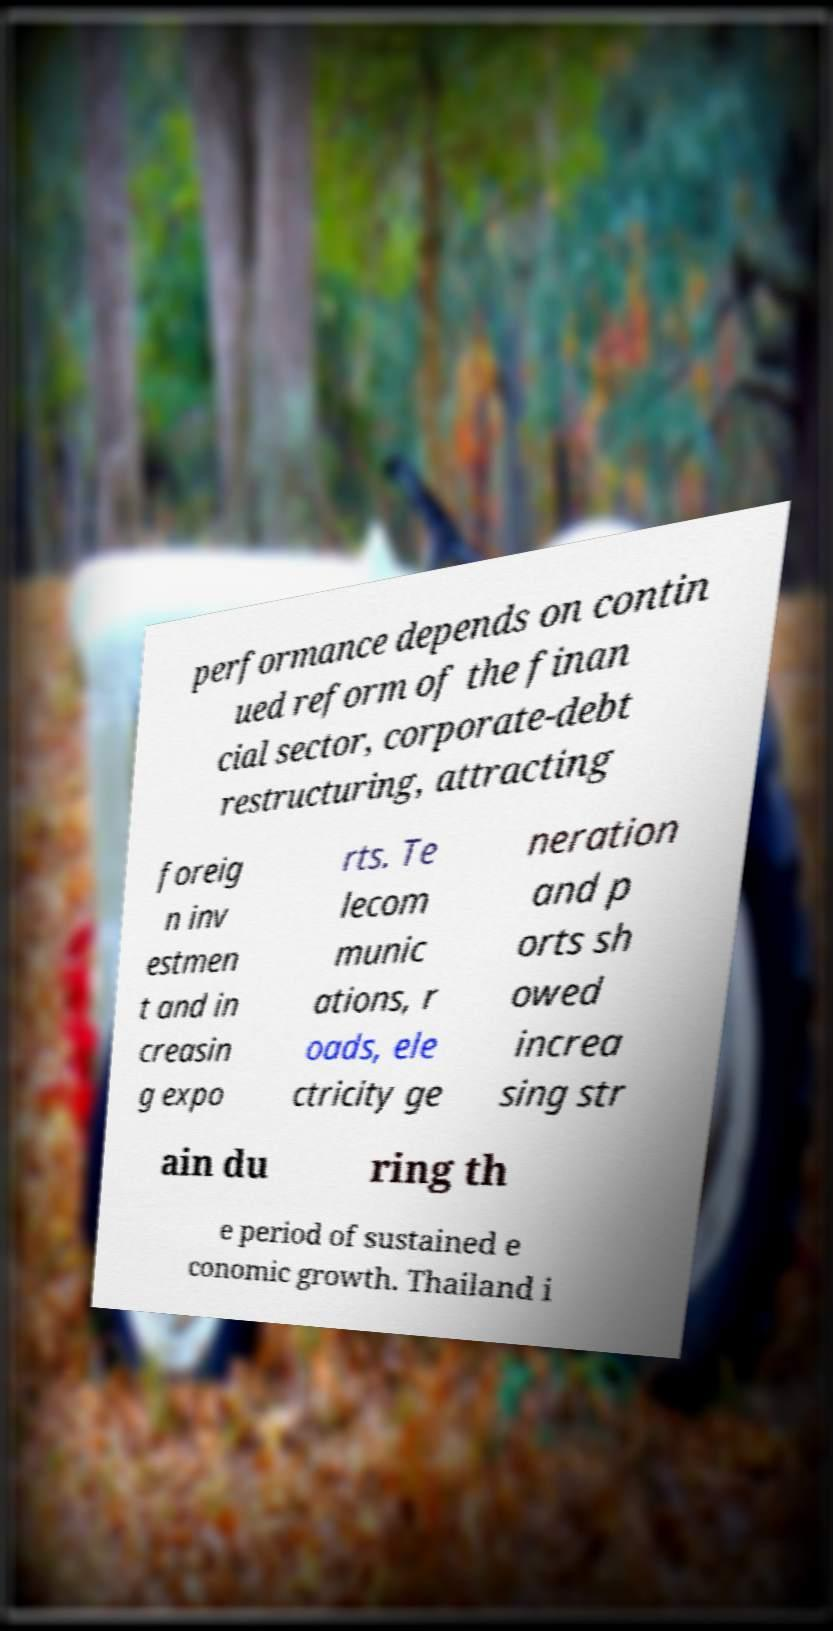What messages or text are displayed in this image? I need them in a readable, typed format. performance depends on contin ued reform of the finan cial sector, corporate-debt restructuring, attracting foreig n inv estmen t and in creasin g expo rts. Te lecom munic ations, r oads, ele ctricity ge neration and p orts sh owed increa sing str ain du ring th e period of sustained e conomic growth. Thailand i 